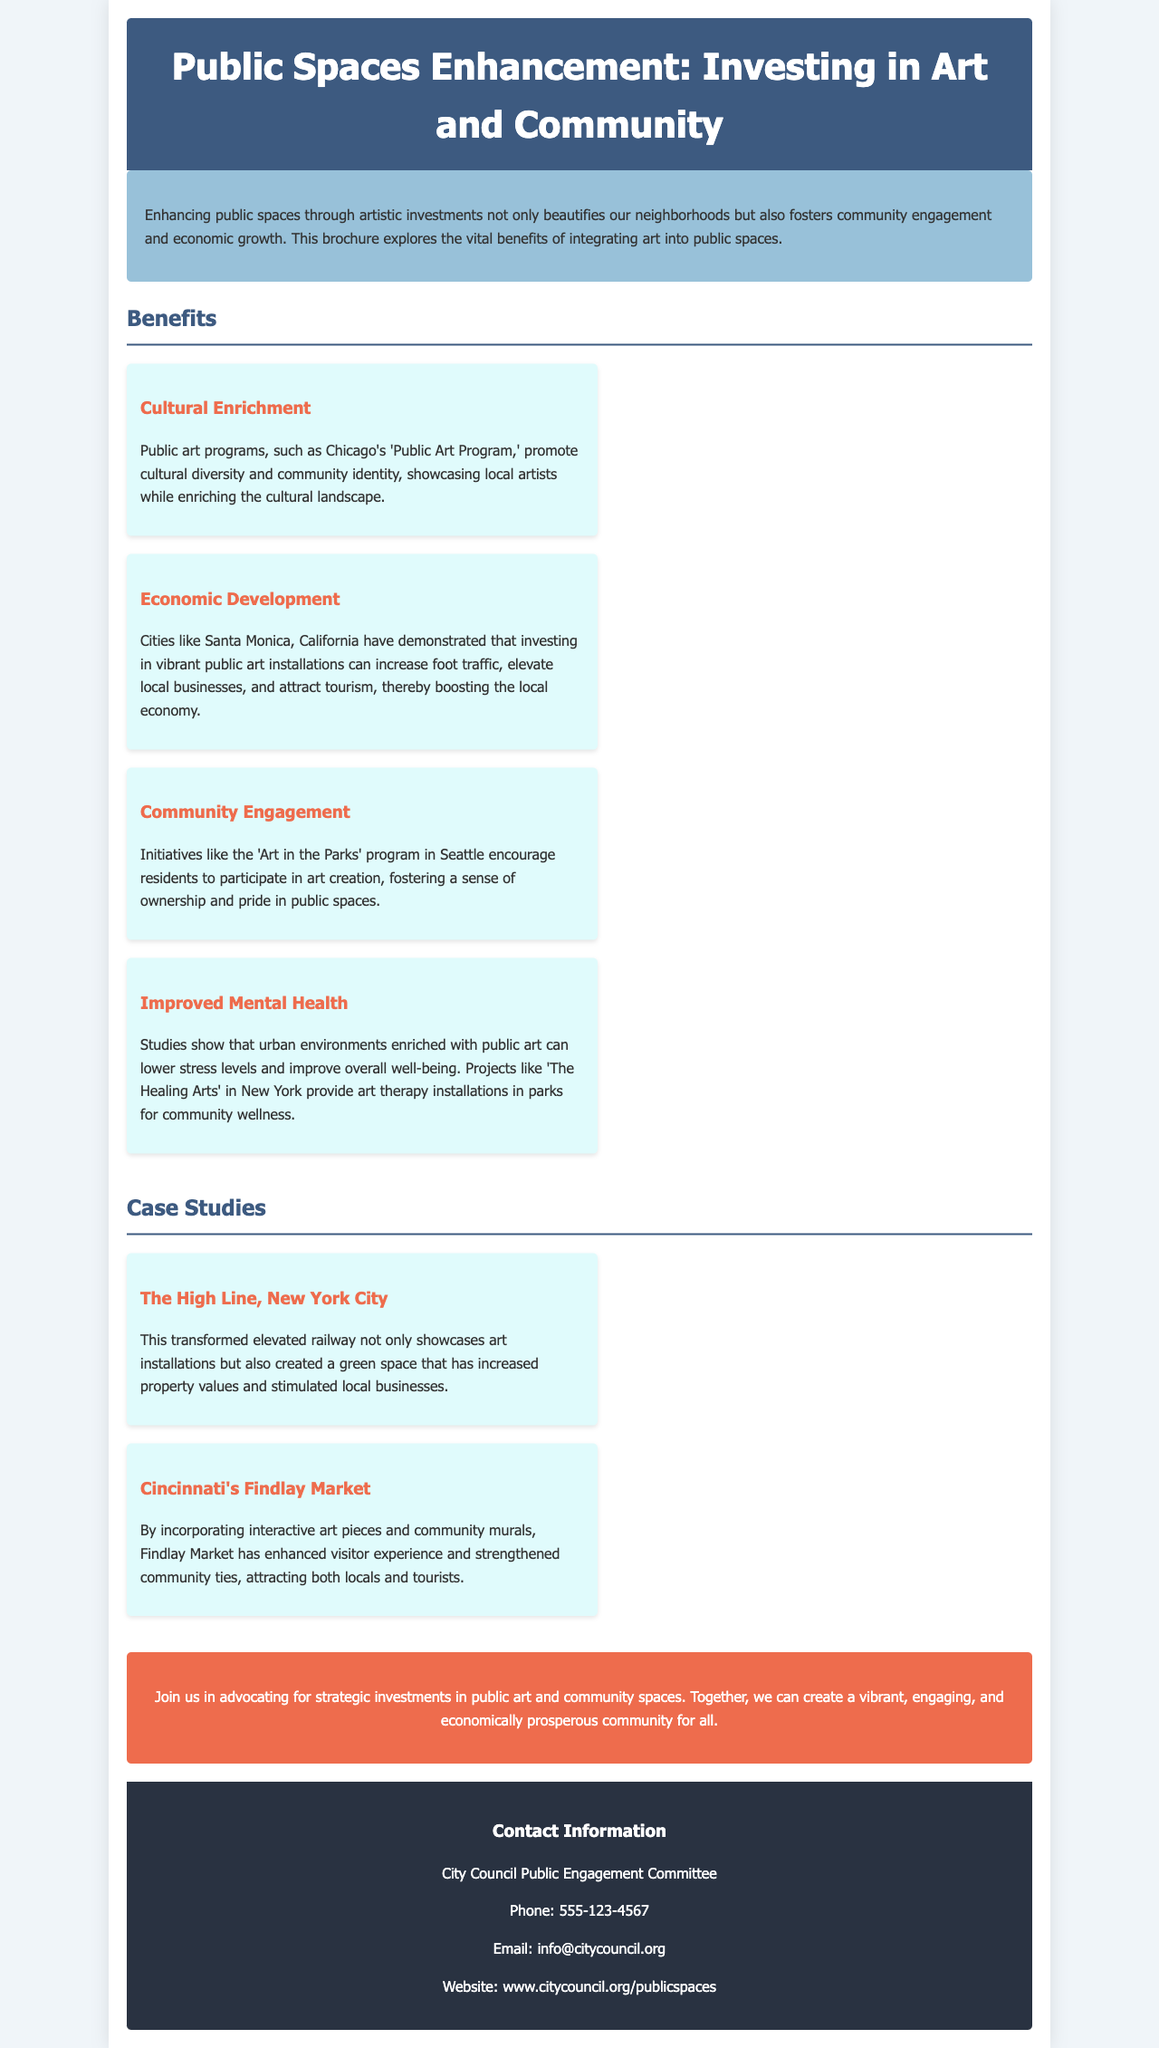What is the title of the brochure? The title displayed prominently at the top of the document is what provides the main topic covered.
Answer: Public Spaces Enhancement: Investing in Art and Community What is one benefit of enhancing public spaces through art? The document lists several benefits, providing insights into what enhancements through art offer to communities.
Answer: Cultural Enrichment Which city has an 'Art in the Parks' program? This detail reflects the specific initiative mentioned in the document that promotes community involvement in art creation.
Answer: Seattle What is one case study mentioned in the brochure? The case studies provide examples that illustrate the document's concepts, highlighting successful public space enhancements.
Answer: The High Line, New York City How can investing in public art affect local businesses? The document discusses the economic impacts on communities, particularly how art installations can benefit local entrepreneurs.
Answer: Increase foot traffic What is the contact information for the City Council Public Engagement Committee? This section provides essential details for readers wanting to reach out regarding the brochure's content or initiatives.
Answer: Phone: 555-123-4567 What color is the header of the brochure? The visual aspect of the header is a specific detail that contributes to the overall design of the brochure.
Answer: Dark blue What does the call-to-action encourage residents to do? This section highlights the main purpose of the brochure, motivating readers towards a specific action related to public art.
Answer: Advocate for strategic investments How does public art impact mental health according to the brochure? This reference provides insight into the psychological benefits mentioned in relation to urban environments enriched with art.
Answer: Improve overall well-being 